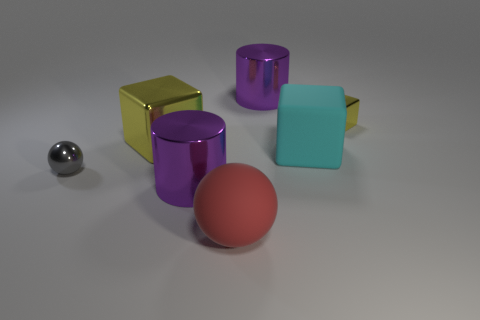Add 1 big things. How many objects exist? 8 Subtract all balls. How many objects are left? 5 Subtract all tiny gray things. Subtract all small yellow objects. How many objects are left? 5 Add 5 big purple metal objects. How many big purple metal objects are left? 7 Add 7 green matte cylinders. How many green matte cylinders exist? 7 Subtract 0 cyan spheres. How many objects are left? 7 